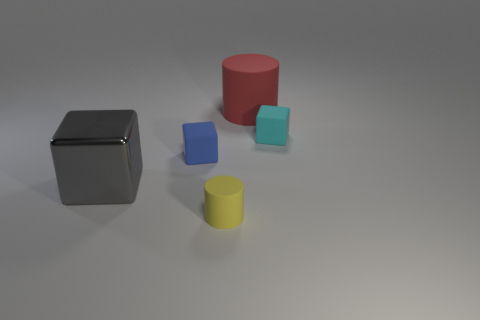Add 1 small gray matte blocks. How many objects exist? 6 Subtract all blocks. How many objects are left? 2 Subtract 1 cylinders. How many cylinders are left? 1 Subtract all brown blocks. Subtract all gray balls. How many blocks are left? 3 Subtract all brown balls. How many green blocks are left? 0 Subtract all big red spheres. Subtract all red cylinders. How many objects are left? 4 Add 5 yellow matte objects. How many yellow matte objects are left? 6 Add 2 large yellow spheres. How many large yellow spheres exist? 2 Subtract all red cylinders. How many cylinders are left? 1 Subtract all large gray metallic blocks. How many blocks are left? 2 